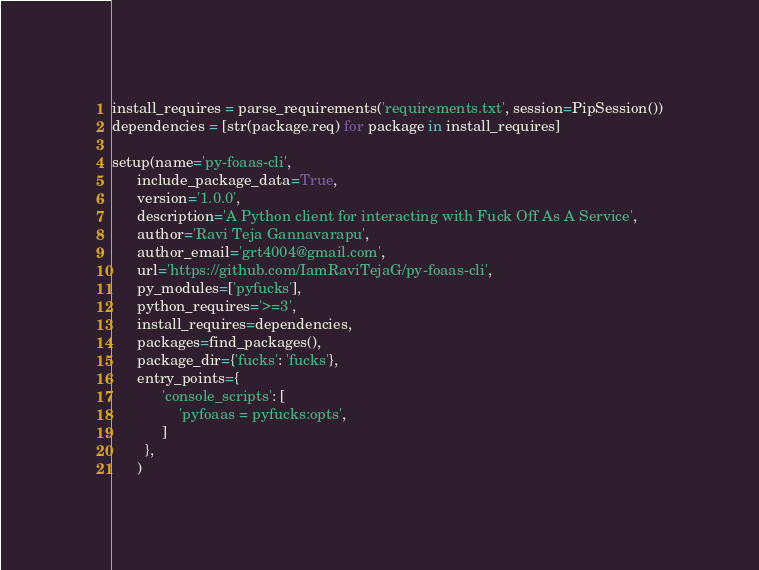Convert code to text. <code><loc_0><loc_0><loc_500><loc_500><_Python_>
install_requires = parse_requirements('requirements.txt', session=PipSession())
dependencies = [str(package.req) for package in install_requires]

setup(name='py-foaas-cli',
      include_package_data=True,
      version='1.0.0',
      description='A Python client for interacting with Fuck Off As A Service',
      author='Ravi Teja Gannavarapu',
      author_email='grt4004@gmail.com',
      url='https://github.com/IamRaviTejaG/py-foaas-cli',
      py_modules=['pyfucks'],
      python_requires='>=3',
      install_requires=dependencies,
      packages=find_packages(),
      package_dir={'fucks': 'fucks'},
      entry_points={
            'console_scripts': [
                'pyfoaas = pyfucks:opts',
            ]
        },
      )
</code> 